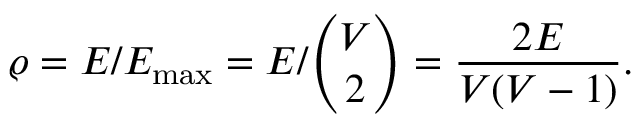<formula> <loc_0><loc_0><loc_500><loc_500>\varrho = E / E _ { \max } = E / \binom { V } { 2 } = \frac { 2 E } { V ( V - 1 ) } .</formula> 